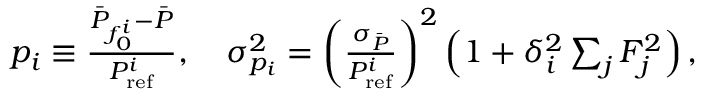<formula> <loc_0><loc_0><loc_500><loc_500>\begin{array} { r } { p _ { i } \equiv \frac { \bar { P } _ { f _ { 0 } ^ { i } } - \bar { P } } { P _ { r e f } ^ { i } } , \quad \sigma _ { p _ { i } } ^ { 2 } = \left ( \frac { \sigma _ { \bar { P } } } { P _ { r e f } ^ { i } } \right ) ^ { 2 } \left ( 1 + \delta _ { i } ^ { 2 } \sum _ { j } F _ { j } ^ { 2 } \right ) , } \end{array}</formula> 